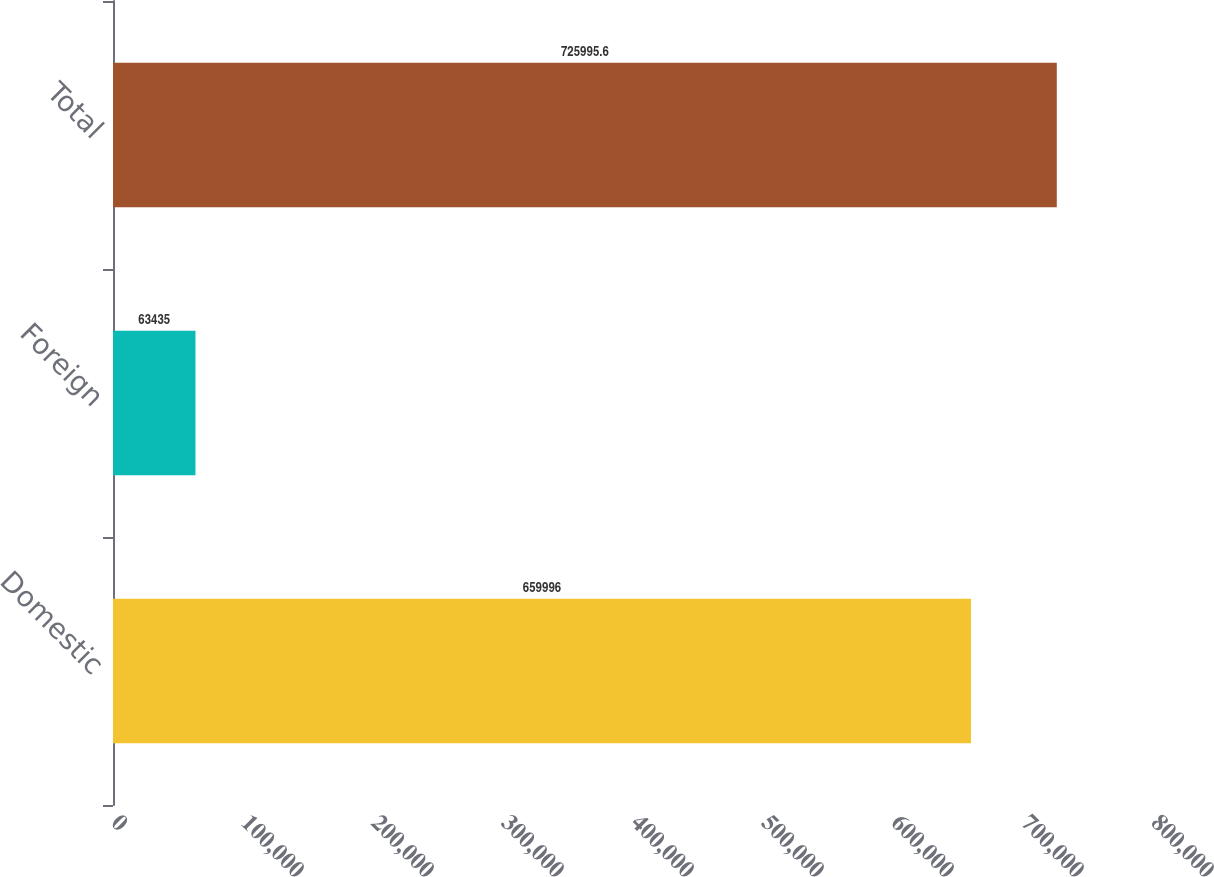Convert chart to OTSL. <chart><loc_0><loc_0><loc_500><loc_500><bar_chart><fcel>Domestic<fcel>Foreign<fcel>Total<nl><fcel>659996<fcel>63435<fcel>725996<nl></chart> 